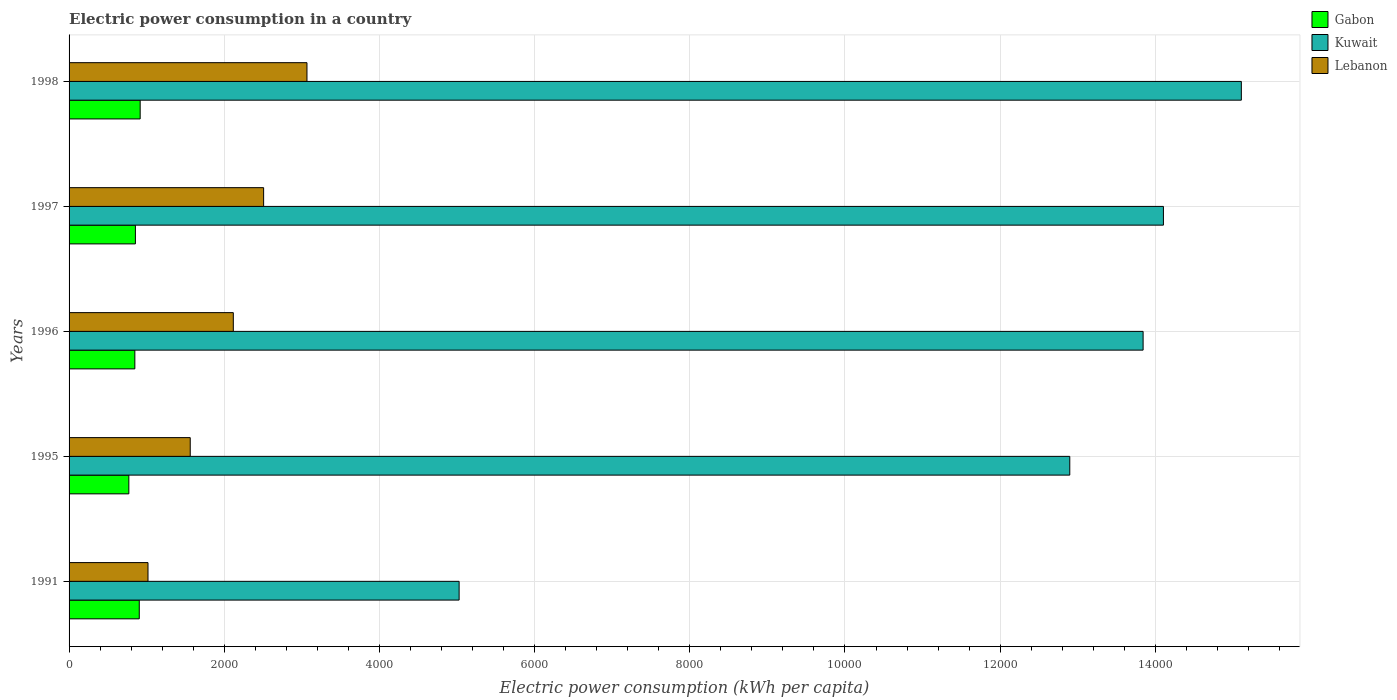How many bars are there on the 1st tick from the top?
Offer a very short reply. 3. How many bars are there on the 2nd tick from the bottom?
Your answer should be very brief. 3. What is the label of the 4th group of bars from the top?
Provide a short and direct response. 1995. In how many cases, is the number of bars for a given year not equal to the number of legend labels?
Make the answer very short. 0. What is the electric power consumption in in Lebanon in 1997?
Your answer should be compact. 2507.53. Across all years, what is the maximum electric power consumption in in Kuwait?
Provide a succinct answer. 1.51e+04. Across all years, what is the minimum electric power consumption in in Lebanon?
Provide a succinct answer. 1017.27. What is the total electric power consumption in in Kuwait in the graph?
Offer a terse response. 6.10e+04. What is the difference between the electric power consumption in in Lebanon in 1995 and that in 1998?
Give a very brief answer. -1504.58. What is the difference between the electric power consumption in in Lebanon in 1996 and the electric power consumption in in Kuwait in 1995?
Provide a short and direct response. -1.08e+04. What is the average electric power consumption in in Kuwait per year?
Your answer should be very brief. 1.22e+04. In the year 1997, what is the difference between the electric power consumption in in Lebanon and electric power consumption in in Gabon?
Give a very brief answer. 1652.51. What is the ratio of the electric power consumption in in Kuwait in 1991 to that in 1995?
Keep it short and to the point. 0.39. Is the difference between the electric power consumption in in Lebanon in 1991 and 1995 greater than the difference between the electric power consumption in in Gabon in 1991 and 1995?
Your answer should be very brief. No. What is the difference between the highest and the second highest electric power consumption in in Gabon?
Your answer should be very brief. 11.69. What is the difference between the highest and the lowest electric power consumption in in Kuwait?
Give a very brief answer. 1.01e+04. Is the sum of the electric power consumption in in Kuwait in 1996 and 1998 greater than the maximum electric power consumption in in Gabon across all years?
Ensure brevity in your answer.  Yes. What does the 1st bar from the top in 1991 represents?
Offer a terse response. Lebanon. What does the 1st bar from the bottom in 1991 represents?
Provide a short and direct response. Gabon. Is it the case that in every year, the sum of the electric power consumption in in Kuwait and electric power consumption in in Gabon is greater than the electric power consumption in in Lebanon?
Your answer should be compact. Yes. How many bars are there?
Ensure brevity in your answer.  15. Are all the bars in the graph horizontal?
Offer a very short reply. Yes. Are the values on the major ticks of X-axis written in scientific E-notation?
Your response must be concise. No. Does the graph contain grids?
Offer a terse response. Yes. How many legend labels are there?
Ensure brevity in your answer.  3. How are the legend labels stacked?
Give a very brief answer. Vertical. What is the title of the graph?
Offer a very short reply. Electric power consumption in a country. Does "OECD members" appear as one of the legend labels in the graph?
Provide a short and direct response. No. What is the label or title of the X-axis?
Your answer should be compact. Electric power consumption (kWh per capita). What is the Electric power consumption (kWh per capita) in Gabon in 1991?
Give a very brief answer. 904.67. What is the Electric power consumption (kWh per capita) of Kuwait in 1991?
Keep it short and to the point. 5027.13. What is the Electric power consumption (kWh per capita) of Lebanon in 1991?
Ensure brevity in your answer.  1017.27. What is the Electric power consumption (kWh per capita) of Gabon in 1995?
Offer a terse response. 770.4. What is the Electric power consumption (kWh per capita) in Kuwait in 1995?
Ensure brevity in your answer.  1.29e+04. What is the Electric power consumption (kWh per capita) of Lebanon in 1995?
Ensure brevity in your answer.  1561.61. What is the Electric power consumption (kWh per capita) in Gabon in 1996?
Provide a short and direct response. 847.63. What is the Electric power consumption (kWh per capita) in Kuwait in 1996?
Provide a short and direct response. 1.38e+04. What is the Electric power consumption (kWh per capita) in Lebanon in 1996?
Provide a succinct answer. 2116.92. What is the Electric power consumption (kWh per capita) in Gabon in 1997?
Your response must be concise. 855.02. What is the Electric power consumption (kWh per capita) in Kuwait in 1997?
Ensure brevity in your answer.  1.41e+04. What is the Electric power consumption (kWh per capita) in Lebanon in 1997?
Keep it short and to the point. 2507.53. What is the Electric power consumption (kWh per capita) in Gabon in 1998?
Make the answer very short. 916.36. What is the Electric power consumption (kWh per capita) in Kuwait in 1998?
Your response must be concise. 1.51e+04. What is the Electric power consumption (kWh per capita) in Lebanon in 1998?
Offer a very short reply. 3066.19. Across all years, what is the maximum Electric power consumption (kWh per capita) of Gabon?
Give a very brief answer. 916.36. Across all years, what is the maximum Electric power consumption (kWh per capita) of Kuwait?
Provide a succinct answer. 1.51e+04. Across all years, what is the maximum Electric power consumption (kWh per capita) in Lebanon?
Offer a terse response. 3066.19. Across all years, what is the minimum Electric power consumption (kWh per capita) of Gabon?
Provide a succinct answer. 770.4. Across all years, what is the minimum Electric power consumption (kWh per capita) in Kuwait?
Provide a succinct answer. 5027.13. Across all years, what is the minimum Electric power consumption (kWh per capita) of Lebanon?
Provide a short and direct response. 1017.27. What is the total Electric power consumption (kWh per capita) of Gabon in the graph?
Keep it short and to the point. 4294.08. What is the total Electric power consumption (kWh per capita) of Kuwait in the graph?
Keep it short and to the point. 6.10e+04. What is the total Electric power consumption (kWh per capita) of Lebanon in the graph?
Your answer should be very brief. 1.03e+04. What is the difference between the Electric power consumption (kWh per capita) of Gabon in 1991 and that in 1995?
Provide a succinct answer. 134.28. What is the difference between the Electric power consumption (kWh per capita) in Kuwait in 1991 and that in 1995?
Make the answer very short. -7870.61. What is the difference between the Electric power consumption (kWh per capita) of Lebanon in 1991 and that in 1995?
Keep it short and to the point. -544.34. What is the difference between the Electric power consumption (kWh per capita) in Gabon in 1991 and that in 1996?
Offer a terse response. 57.05. What is the difference between the Electric power consumption (kWh per capita) in Kuwait in 1991 and that in 1996?
Your answer should be very brief. -8815.55. What is the difference between the Electric power consumption (kWh per capita) of Lebanon in 1991 and that in 1996?
Make the answer very short. -1099.65. What is the difference between the Electric power consumption (kWh per capita) of Gabon in 1991 and that in 1997?
Your response must be concise. 49.66. What is the difference between the Electric power consumption (kWh per capita) of Kuwait in 1991 and that in 1997?
Ensure brevity in your answer.  -9077.49. What is the difference between the Electric power consumption (kWh per capita) in Lebanon in 1991 and that in 1997?
Offer a very short reply. -1490.26. What is the difference between the Electric power consumption (kWh per capita) of Gabon in 1991 and that in 1998?
Your response must be concise. -11.69. What is the difference between the Electric power consumption (kWh per capita) in Kuwait in 1991 and that in 1998?
Your answer should be compact. -1.01e+04. What is the difference between the Electric power consumption (kWh per capita) of Lebanon in 1991 and that in 1998?
Your answer should be compact. -2048.93. What is the difference between the Electric power consumption (kWh per capita) of Gabon in 1995 and that in 1996?
Keep it short and to the point. -77.23. What is the difference between the Electric power consumption (kWh per capita) in Kuwait in 1995 and that in 1996?
Provide a succinct answer. -944.93. What is the difference between the Electric power consumption (kWh per capita) of Lebanon in 1995 and that in 1996?
Ensure brevity in your answer.  -555.31. What is the difference between the Electric power consumption (kWh per capita) of Gabon in 1995 and that in 1997?
Give a very brief answer. -84.62. What is the difference between the Electric power consumption (kWh per capita) in Kuwait in 1995 and that in 1997?
Provide a succinct answer. -1206.88. What is the difference between the Electric power consumption (kWh per capita) in Lebanon in 1995 and that in 1997?
Make the answer very short. -945.92. What is the difference between the Electric power consumption (kWh per capita) in Gabon in 1995 and that in 1998?
Ensure brevity in your answer.  -145.96. What is the difference between the Electric power consumption (kWh per capita) in Kuwait in 1995 and that in 1998?
Make the answer very short. -2211.13. What is the difference between the Electric power consumption (kWh per capita) of Lebanon in 1995 and that in 1998?
Provide a short and direct response. -1504.58. What is the difference between the Electric power consumption (kWh per capita) of Gabon in 1996 and that in 1997?
Make the answer very short. -7.39. What is the difference between the Electric power consumption (kWh per capita) of Kuwait in 1996 and that in 1997?
Your response must be concise. -261.95. What is the difference between the Electric power consumption (kWh per capita) of Lebanon in 1996 and that in 1997?
Give a very brief answer. -390.61. What is the difference between the Electric power consumption (kWh per capita) in Gabon in 1996 and that in 1998?
Give a very brief answer. -68.74. What is the difference between the Electric power consumption (kWh per capita) of Kuwait in 1996 and that in 1998?
Your answer should be very brief. -1266.2. What is the difference between the Electric power consumption (kWh per capita) in Lebanon in 1996 and that in 1998?
Your answer should be compact. -949.27. What is the difference between the Electric power consumption (kWh per capita) in Gabon in 1997 and that in 1998?
Your answer should be very brief. -61.35. What is the difference between the Electric power consumption (kWh per capita) in Kuwait in 1997 and that in 1998?
Offer a very short reply. -1004.25. What is the difference between the Electric power consumption (kWh per capita) of Lebanon in 1997 and that in 1998?
Your answer should be very brief. -558.66. What is the difference between the Electric power consumption (kWh per capita) in Gabon in 1991 and the Electric power consumption (kWh per capita) in Kuwait in 1995?
Offer a very short reply. -1.20e+04. What is the difference between the Electric power consumption (kWh per capita) of Gabon in 1991 and the Electric power consumption (kWh per capita) of Lebanon in 1995?
Ensure brevity in your answer.  -656.94. What is the difference between the Electric power consumption (kWh per capita) in Kuwait in 1991 and the Electric power consumption (kWh per capita) in Lebanon in 1995?
Offer a terse response. 3465.52. What is the difference between the Electric power consumption (kWh per capita) of Gabon in 1991 and the Electric power consumption (kWh per capita) of Kuwait in 1996?
Your answer should be very brief. -1.29e+04. What is the difference between the Electric power consumption (kWh per capita) of Gabon in 1991 and the Electric power consumption (kWh per capita) of Lebanon in 1996?
Offer a very short reply. -1212.24. What is the difference between the Electric power consumption (kWh per capita) of Kuwait in 1991 and the Electric power consumption (kWh per capita) of Lebanon in 1996?
Your response must be concise. 2910.21. What is the difference between the Electric power consumption (kWh per capita) in Gabon in 1991 and the Electric power consumption (kWh per capita) in Kuwait in 1997?
Give a very brief answer. -1.32e+04. What is the difference between the Electric power consumption (kWh per capita) of Gabon in 1991 and the Electric power consumption (kWh per capita) of Lebanon in 1997?
Keep it short and to the point. -1602.86. What is the difference between the Electric power consumption (kWh per capita) in Kuwait in 1991 and the Electric power consumption (kWh per capita) in Lebanon in 1997?
Offer a terse response. 2519.6. What is the difference between the Electric power consumption (kWh per capita) in Gabon in 1991 and the Electric power consumption (kWh per capita) in Kuwait in 1998?
Provide a succinct answer. -1.42e+04. What is the difference between the Electric power consumption (kWh per capita) of Gabon in 1991 and the Electric power consumption (kWh per capita) of Lebanon in 1998?
Your response must be concise. -2161.52. What is the difference between the Electric power consumption (kWh per capita) of Kuwait in 1991 and the Electric power consumption (kWh per capita) of Lebanon in 1998?
Your answer should be very brief. 1960.94. What is the difference between the Electric power consumption (kWh per capita) in Gabon in 1995 and the Electric power consumption (kWh per capita) in Kuwait in 1996?
Your answer should be compact. -1.31e+04. What is the difference between the Electric power consumption (kWh per capita) of Gabon in 1995 and the Electric power consumption (kWh per capita) of Lebanon in 1996?
Make the answer very short. -1346.52. What is the difference between the Electric power consumption (kWh per capita) in Kuwait in 1995 and the Electric power consumption (kWh per capita) in Lebanon in 1996?
Make the answer very short. 1.08e+04. What is the difference between the Electric power consumption (kWh per capita) of Gabon in 1995 and the Electric power consumption (kWh per capita) of Kuwait in 1997?
Provide a short and direct response. -1.33e+04. What is the difference between the Electric power consumption (kWh per capita) in Gabon in 1995 and the Electric power consumption (kWh per capita) in Lebanon in 1997?
Give a very brief answer. -1737.13. What is the difference between the Electric power consumption (kWh per capita) of Kuwait in 1995 and the Electric power consumption (kWh per capita) of Lebanon in 1997?
Offer a terse response. 1.04e+04. What is the difference between the Electric power consumption (kWh per capita) in Gabon in 1995 and the Electric power consumption (kWh per capita) in Kuwait in 1998?
Offer a terse response. -1.43e+04. What is the difference between the Electric power consumption (kWh per capita) of Gabon in 1995 and the Electric power consumption (kWh per capita) of Lebanon in 1998?
Ensure brevity in your answer.  -2295.79. What is the difference between the Electric power consumption (kWh per capita) in Kuwait in 1995 and the Electric power consumption (kWh per capita) in Lebanon in 1998?
Ensure brevity in your answer.  9831.55. What is the difference between the Electric power consumption (kWh per capita) of Gabon in 1996 and the Electric power consumption (kWh per capita) of Kuwait in 1997?
Provide a short and direct response. -1.33e+04. What is the difference between the Electric power consumption (kWh per capita) of Gabon in 1996 and the Electric power consumption (kWh per capita) of Lebanon in 1997?
Your response must be concise. -1659.91. What is the difference between the Electric power consumption (kWh per capita) of Kuwait in 1996 and the Electric power consumption (kWh per capita) of Lebanon in 1997?
Offer a very short reply. 1.13e+04. What is the difference between the Electric power consumption (kWh per capita) in Gabon in 1996 and the Electric power consumption (kWh per capita) in Kuwait in 1998?
Your answer should be very brief. -1.43e+04. What is the difference between the Electric power consumption (kWh per capita) of Gabon in 1996 and the Electric power consumption (kWh per capita) of Lebanon in 1998?
Your response must be concise. -2218.57. What is the difference between the Electric power consumption (kWh per capita) of Kuwait in 1996 and the Electric power consumption (kWh per capita) of Lebanon in 1998?
Provide a succinct answer. 1.08e+04. What is the difference between the Electric power consumption (kWh per capita) of Gabon in 1997 and the Electric power consumption (kWh per capita) of Kuwait in 1998?
Offer a very short reply. -1.43e+04. What is the difference between the Electric power consumption (kWh per capita) in Gabon in 1997 and the Electric power consumption (kWh per capita) in Lebanon in 1998?
Offer a terse response. -2211.18. What is the difference between the Electric power consumption (kWh per capita) in Kuwait in 1997 and the Electric power consumption (kWh per capita) in Lebanon in 1998?
Keep it short and to the point. 1.10e+04. What is the average Electric power consumption (kWh per capita) in Gabon per year?
Make the answer very short. 858.82. What is the average Electric power consumption (kWh per capita) in Kuwait per year?
Your response must be concise. 1.22e+04. What is the average Electric power consumption (kWh per capita) of Lebanon per year?
Provide a short and direct response. 2053.9. In the year 1991, what is the difference between the Electric power consumption (kWh per capita) of Gabon and Electric power consumption (kWh per capita) of Kuwait?
Give a very brief answer. -4122.45. In the year 1991, what is the difference between the Electric power consumption (kWh per capita) of Gabon and Electric power consumption (kWh per capita) of Lebanon?
Your response must be concise. -112.59. In the year 1991, what is the difference between the Electric power consumption (kWh per capita) of Kuwait and Electric power consumption (kWh per capita) of Lebanon?
Provide a succinct answer. 4009.86. In the year 1995, what is the difference between the Electric power consumption (kWh per capita) of Gabon and Electric power consumption (kWh per capita) of Kuwait?
Offer a terse response. -1.21e+04. In the year 1995, what is the difference between the Electric power consumption (kWh per capita) of Gabon and Electric power consumption (kWh per capita) of Lebanon?
Make the answer very short. -791.21. In the year 1995, what is the difference between the Electric power consumption (kWh per capita) of Kuwait and Electric power consumption (kWh per capita) of Lebanon?
Keep it short and to the point. 1.13e+04. In the year 1996, what is the difference between the Electric power consumption (kWh per capita) of Gabon and Electric power consumption (kWh per capita) of Kuwait?
Keep it short and to the point. -1.30e+04. In the year 1996, what is the difference between the Electric power consumption (kWh per capita) of Gabon and Electric power consumption (kWh per capita) of Lebanon?
Give a very brief answer. -1269.29. In the year 1996, what is the difference between the Electric power consumption (kWh per capita) of Kuwait and Electric power consumption (kWh per capita) of Lebanon?
Offer a terse response. 1.17e+04. In the year 1997, what is the difference between the Electric power consumption (kWh per capita) of Gabon and Electric power consumption (kWh per capita) of Kuwait?
Make the answer very short. -1.32e+04. In the year 1997, what is the difference between the Electric power consumption (kWh per capita) of Gabon and Electric power consumption (kWh per capita) of Lebanon?
Offer a very short reply. -1652.51. In the year 1997, what is the difference between the Electric power consumption (kWh per capita) in Kuwait and Electric power consumption (kWh per capita) in Lebanon?
Provide a succinct answer. 1.16e+04. In the year 1998, what is the difference between the Electric power consumption (kWh per capita) of Gabon and Electric power consumption (kWh per capita) of Kuwait?
Give a very brief answer. -1.42e+04. In the year 1998, what is the difference between the Electric power consumption (kWh per capita) in Gabon and Electric power consumption (kWh per capita) in Lebanon?
Provide a short and direct response. -2149.83. In the year 1998, what is the difference between the Electric power consumption (kWh per capita) in Kuwait and Electric power consumption (kWh per capita) in Lebanon?
Make the answer very short. 1.20e+04. What is the ratio of the Electric power consumption (kWh per capita) of Gabon in 1991 to that in 1995?
Give a very brief answer. 1.17. What is the ratio of the Electric power consumption (kWh per capita) in Kuwait in 1991 to that in 1995?
Offer a terse response. 0.39. What is the ratio of the Electric power consumption (kWh per capita) of Lebanon in 1991 to that in 1995?
Provide a succinct answer. 0.65. What is the ratio of the Electric power consumption (kWh per capita) in Gabon in 1991 to that in 1996?
Offer a very short reply. 1.07. What is the ratio of the Electric power consumption (kWh per capita) of Kuwait in 1991 to that in 1996?
Ensure brevity in your answer.  0.36. What is the ratio of the Electric power consumption (kWh per capita) in Lebanon in 1991 to that in 1996?
Your answer should be compact. 0.48. What is the ratio of the Electric power consumption (kWh per capita) of Gabon in 1991 to that in 1997?
Your answer should be compact. 1.06. What is the ratio of the Electric power consumption (kWh per capita) in Kuwait in 1991 to that in 1997?
Provide a succinct answer. 0.36. What is the ratio of the Electric power consumption (kWh per capita) in Lebanon in 1991 to that in 1997?
Your response must be concise. 0.41. What is the ratio of the Electric power consumption (kWh per capita) in Gabon in 1991 to that in 1998?
Keep it short and to the point. 0.99. What is the ratio of the Electric power consumption (kWh per capita) of Kuwait in 1991 to that in 1998?
Provide a short and direct response. 0.33. What is the ratio of the Electric power consumption (kWh per capita) of Lebanon in 1991 to that in 1998?
Offer a terse response. 0.33. What is the ratio of the Electric power consumption (kWh per capita) of Gabon in 1995 to that in 1996?
Give a very brief answer. 0.91. What is the ratio of the Electric power consumption (kWh per capita) in Kuwait in 1995 to that in 1996?
Your response must be concise. 0.93. What is the ratio of the Electric power consumption (kWh per capita) of Lebanon in 1995 to that in 1996?
Provide a succinct answer. 0.74. What is the ratio of the Electric power consumption (kWh per capita) of Gabon in 1995 to that in 1997?
Keep it short and to the point. 0.9. What is the ratio of the Electric power consumption (kWh per capita) in Kuwait in 1995 to that in 1997?
Offer a very short reply. 0.91. What is the ratio of the Electric power consumption (kWh per capita) in Lebanon in 1995 to that in 1997?
Keep it short and to the point. 0.62. What is the ratio of the Electric power consumption (kWh per capita) of Gabon in 1995 to that in 1998?
Your response must be concise. 0.84. What is the ratio of the Electric power consumption (kWh per capita) of Kuwait in 1995 to that in 1998?
Provide a short and direct response. 0.85. What is the ratio of the Electric power consumption (kWh per capita) in Lebanon in 1995 to that in 1998?
Your answer should be compact. 0.51. What is the ratio of the Electric power consumption (kWh per capita) of Gabon in 1996 to that in 1997?
Your response must be concise. 0.99. What is the ratio of the Electric power consumption (kWh per capita) in Kuwait in 1996 to that in 1997?
Your answer should be compact. 0.98. What is the ratio of the Electric power consumption (kWh per capita) of Lebanon in 1996 to that in 1997?
Provide a succinct answer. 0.84. What is the ratio of the Electric power consumption (kWh per capita) in Gabon in 1996 to that in 1998?
Make the answer very short. 0.93. What is the ratio of the Electric power consumption (kWh per capita) of Kuwait in 1996 to that in 1998?
Offer a very short reply. 0.92. What is the ratio of the Electric power consumption (kWh per capita) of Lebanon in 1996 to that in 1998?
Your answer should be very brief. 0.69. What is the ratio of the Electric power consumption (kWh per capita) in Gabon in 1997 to that in 1998?
Offer a very short reply. 0.93. What is the ratio of the Electric power consumption (kWh per capita) of Kuwait in 1997 to that in 1998?
Offer a terse response. 0.93. What is the ratio of the Electric power consumption (kWh per capita) in Lebanon in 1997 to that in 1998?
Keep it short and to the point. 0.82. What is the difference between the highest and the second highest Electric power consumption (kWh per capita) in Gabon?
Keep it short and to the point. 11.69. What is the difference between the highest and the second highest Electric power consumption (kWh per capita) in Kuwait?
Ensure brevity in your answer.  1004.25. What is the difference between the highest and the second highest Electric power consumption (kWh per capita) of Lebanon?
Offer a terse response. 558.66. What is the difference between the highest and the lowest Electric power consumption (kWh per capita) of Gabon?
Your response must be concise. 145.96. What is the difference between the highest and the lowest Electric power consumption (kWh per capita) in Kuwait?
Ensure brevity in your answer.  1.01e+04. What is the difference between the highest and the lowest Electric power consumption (kWh per capita) of Lebanon?
Give a very brief answer. 2048.93. 